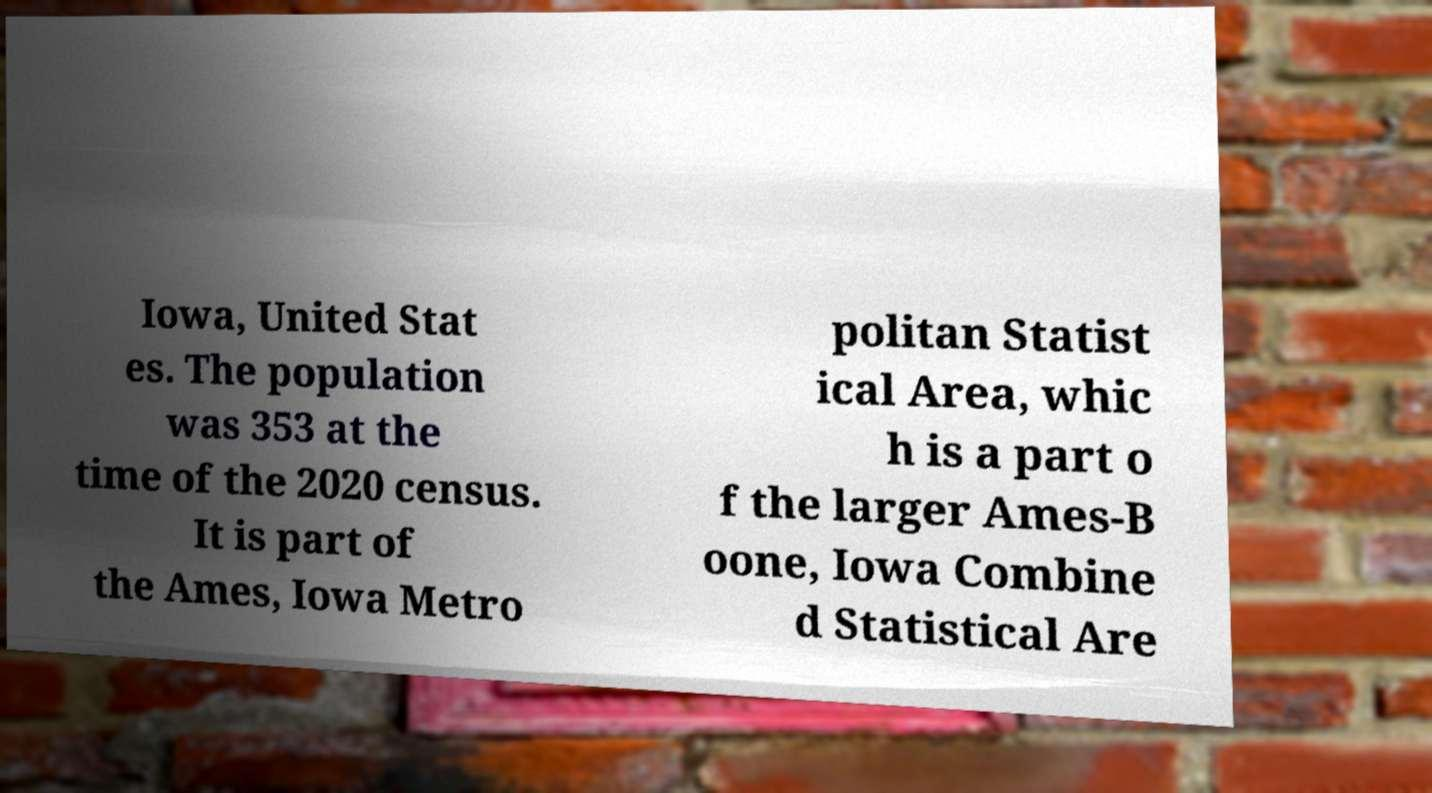Please read and relay the text visible in this image. What does it say? Iowa, United Stat es. The population was 353 at the time of the 2020 census. It is part of the Ames, Iowa Metro politan Statist ical Area, whic h is a part o f the larger Ames-B oone, Iowa Combine d Statistical Are 